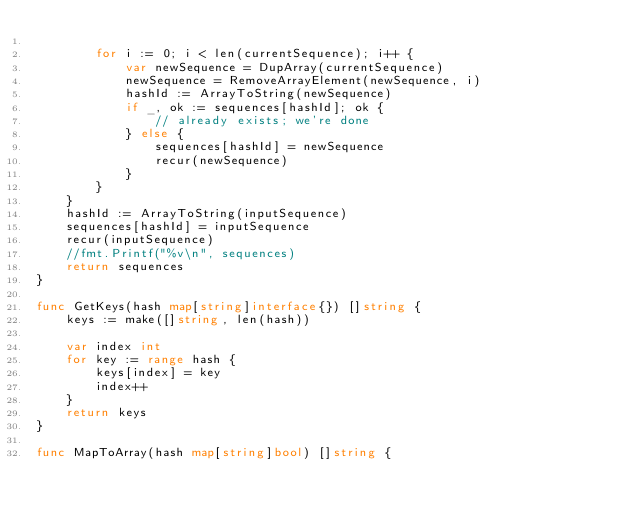<code> <loc_0><loc_0><loc_500><loc_500><_Go_>
		for i := 0; i < len(currentSequence); i++ {
			var newSequence = DupArray(currentSequence)
			newSequence = RemoveArrayElement(newSequence, i)
			hashId := ArrayToString(newSequence)
			if _, ok := sequences[hashId]; ok {
				// already exists; we're done
			} else {
				sequences[hashId] = newSequence
				recur(newSequence)
			}
		}
	}
	hashId := ArrayToString(inputSequence)
	sequences[hashId] = inputSequence
	recur(inputSequence)
	//fmt.Printf("%v\n", sequences)
	return sequences
}

func GetKeys(hash map[string]interface{}) []string {
	keys := make([]string, len(hash))

	var index int
	for key := range hash {
		keys[index] = key
		index++
	}
	return keys
}

func MapToArray(hash map[string]bool) []string {</code> 